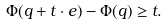Convert formula to latex. <formula><loc_0><loc_0><loc_500><loc_500>\Phi ( q + t \cdot e ) - \Phi ( q ) \geq t .</formula> 